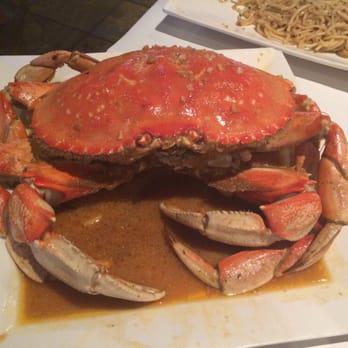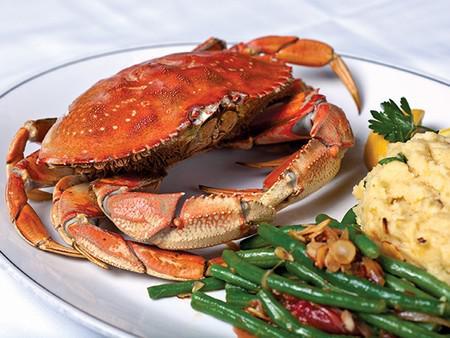The first image is the image on the left, the second image is the image on the right. Examine the images to the left and right. Is the description "One image shows one crab on a plate next to green beans, and the other image shows at least one crab that is facing forward and not on a plate with other food items." accurate? Answer yes or no. Yes. The first image is the image on the left, the second image is the image on the right. For the images displayed, is the sentence "Green vegetables are served in the plate with the crab in one of the dishes." factually correct? Answer yes or no. Yes. 